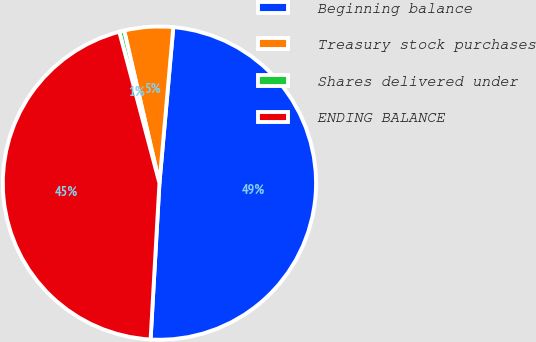<chart> <loc_0><loc_0><loc_500><loc_500><pie_chart><fcel>Beginning balance<fcel>Treasury stock purchases<fcel>Shares delivered under<fcel>ENDING BALANCE<nl><fcel>49.49%<fcel>5.03%<fcel>0.51%<fcel>44.97%<nl></chart> 